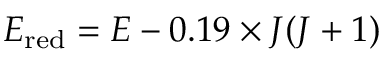Convert formula to latex. <formula><loc_0><loc_0><loc_500><loc_500>E _ { r e d } = E - 0 . 1 9 \times J ( J + 1 )</formula> 